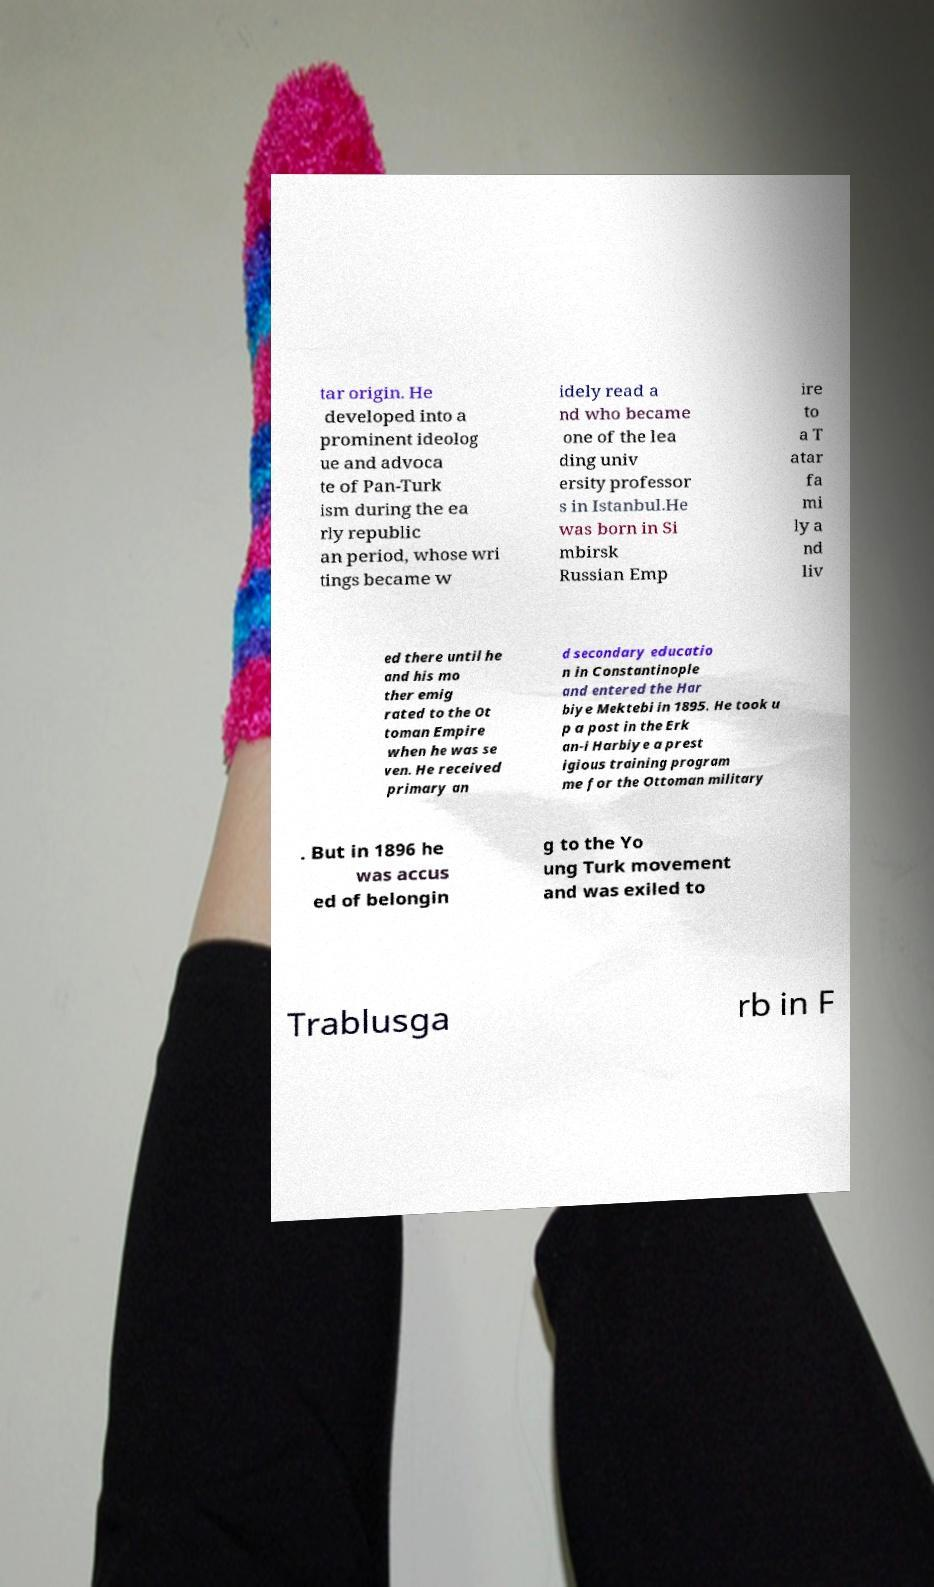Can you accurately transcribe the text from the provided image for me? tar origin. He developed into a prominent ideolog ue and advoca te of Pan-Turk ism during the ea rly republic an period, whose wri tings became w idely read a nd who became one of the lea ding univ ersity professor s in Istanbul.He was born in Si mbirsk Russian Emp ire to a T atar fa mi ly a nd liv ed there until he and his mo ther emig rated to the Ot toman Empire when he was se ven. He received primary an d secondary educatio n in Constantinople and entered the Har biye Mektebi in 1895. He took u p a post in the Erk an-i Harbiye a prest igious training program me for the Ottoman military . But in 1896 he was accus ed of belongin g to the Yo ung Turk movement and was exiled to Trablusga rb in F 